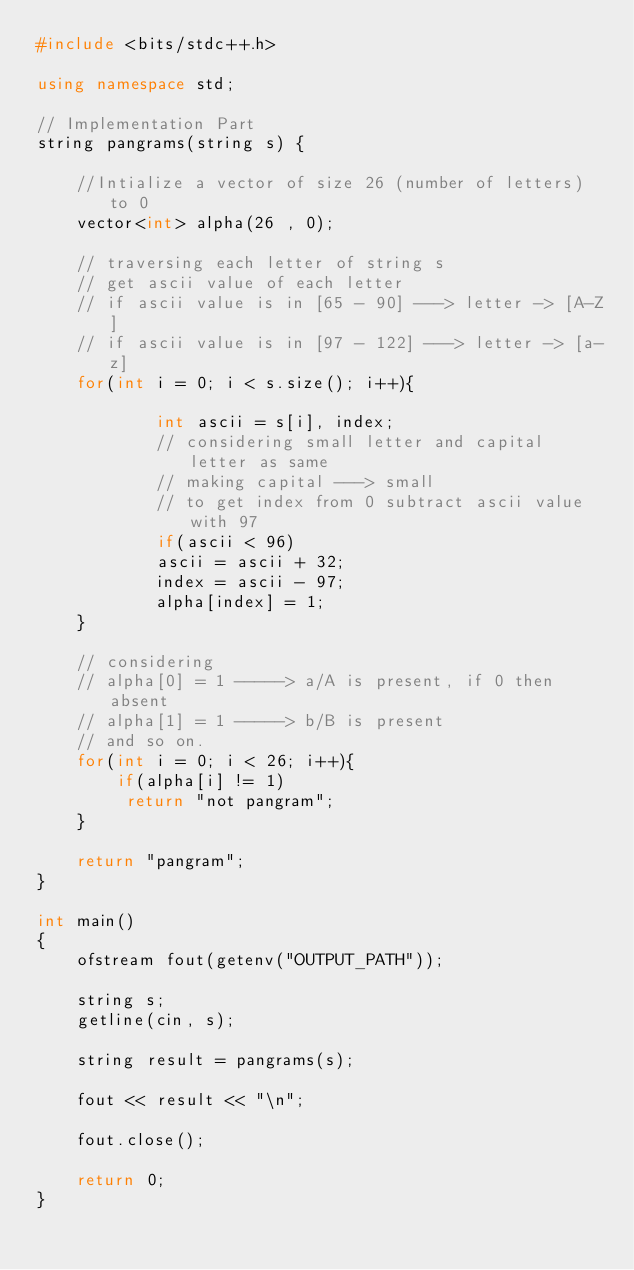<code> <loc_0><loc_0><loc_500><loc_500><_C++_>#include <bits/stdc++.h>

using namespace std;

// Implementation Part
string pangrams(string s) {
    
    //Intialize a vector of size 26 (number of letters) to 0
    vector<int> alpha(26 , 0);
    
    // traversing each letter of string s
    // get ascii value of each letter
    // if ascii value is in [65 - 90] ---> letter -> [A-Z]
    // if ascii value is in [97 - 122] ---> letter -> [a-z]
    for(int i = 0; i < s.size(); i++){

            int ascii = s[i], index;
            // considering small letter and capital letter as same
            // making capital ---> small
            // to get index from 0 subtract ascii value with 97
            if(ascii < 96)
            ascii = ascii + 32;
            index = ascii - 97;
            alpha[index] = 1;
    }
    
    // considering 
    // alpha[0] = 1 -----> a/A is present, if 0 then absent
    // alpha[1] = 1 -----> b/B is present
    // and so on.
    for(int i = 0; i < 26; i++){
        if(alpha[i] != 1)
         return "not pangram";
    }
    
    return "pangram";
}

int main()
{
    ofstream fout(getenv("OUTPUT_PATH"));

    string s;
    getline(cin, s);

    string result = pangrams(s);

    fout << result << "\n";

    fout.close();

    return 0;
}

</code> 